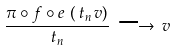<formula> <loc_0><loc_0><loc_500><loc_500>\frac { \pi \circ f \circ e \, \left ( \, t _ { n } \, v \right ) } { t _ { n } } \, \longrightarrow \, v</formula> 